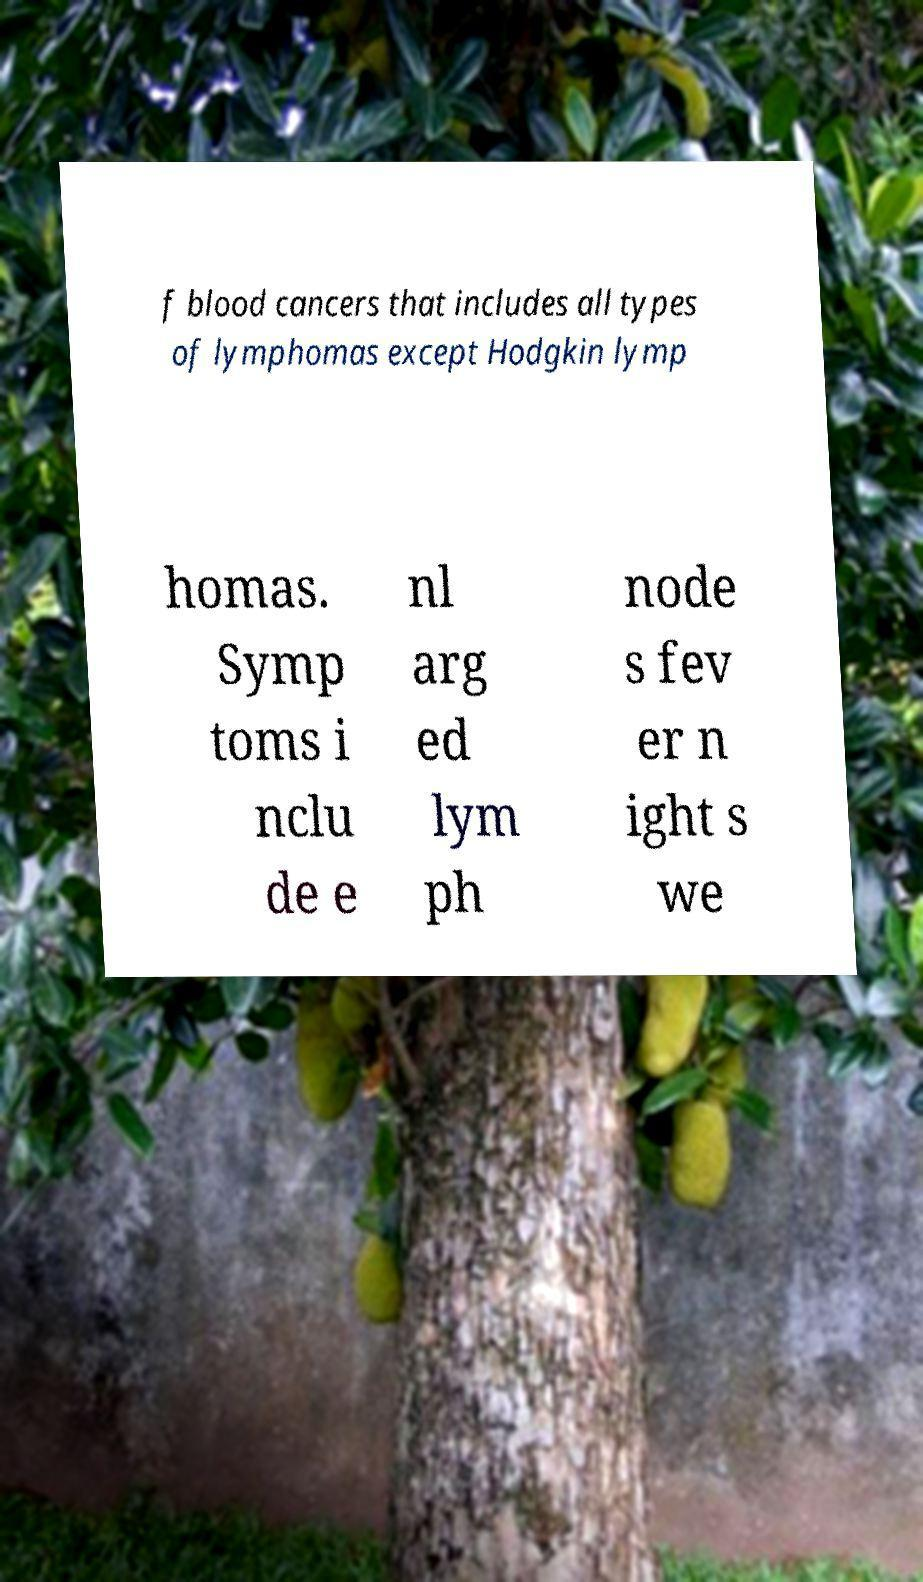Can you accurately transcribe the text from the provided image for me? f blood cancers that includes all types of lymphomas except Hodgkin lymp homas. Symp toms i nclu de e nl arg ed lym ph node s fev er n ight s we 